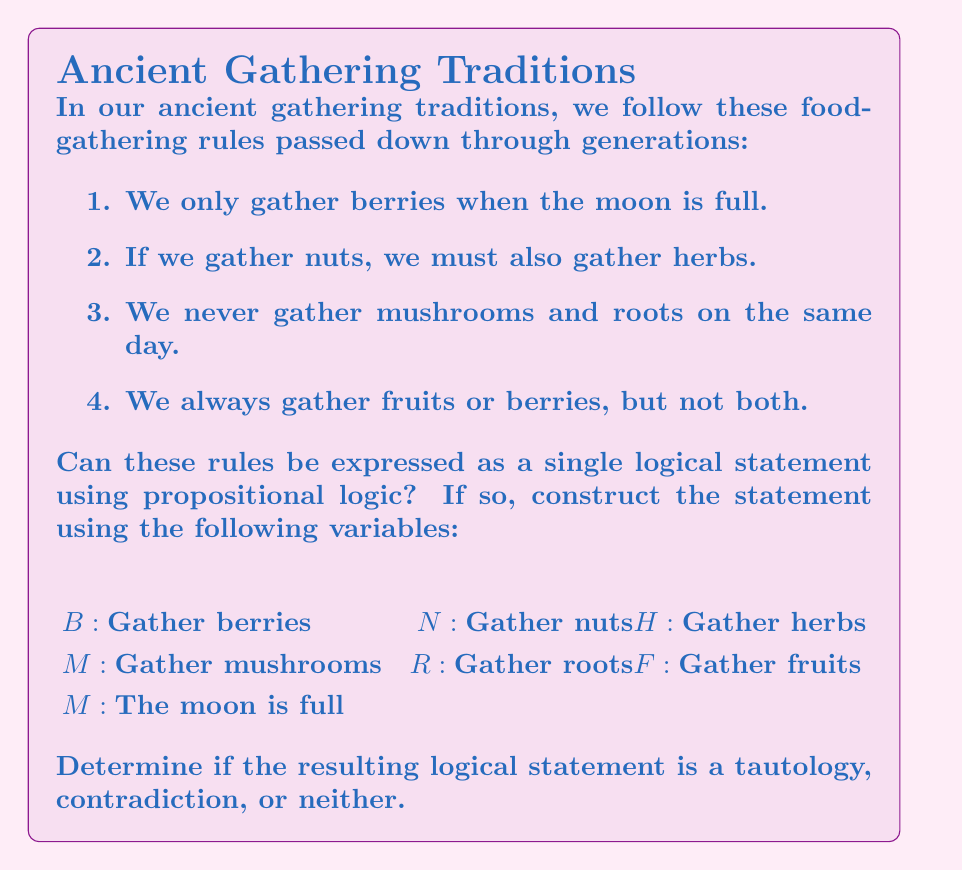Can you answer this question? Let's approach this step-by-step:

1) First, we need to translate each rule into a logical statement:

   Rule 1: $B \rightarrow M$
   Rule 2: $N \rightarrow H$
   Rule 3: $\neg(M \wedge R)$
   Rule 4: $(F \oplus B)$ (exclusive or)

2) Now, we combine these statements using conjunction ($\wedge$):

   $$(B \rightarrow M) \wedge (N \rightarrow H) \wedge \neg(M \wedge R) \wedge (F \oplus B)$$

3) This is our single logical statement representing all the rules.

4) To determine if this is a tautology, contradiction, or neither, we need to evaluate it for all possible combinations of truth values for the variables.

5) With 7 variables, we have $2^7 = 128$ possible combinations. This is too many to check manually, so we would typically use a truth table or a computer program.

6) Without exhaustive checking, we can reason about it:
   - The statement is not a tautology because we can find at least one false case. For example, if all variables are false, $(F \oplus B)$ would be false.
   - The statement is not a contradiction because we can find at least one true case. For example, if M is true, B is false, N is false, H is false, R is false, and F is true, the entire statement would be true.

7) Therefore, the statement is neither a tautology nor a contradiction. It's a contingency, which means its truth value depends on the specific values of the variables.
Answer: The rules can be expressed as: $$(B \rightarrow M) \wedge (N \rightarrow H) \wedge \neg(M \wedge R) \wedge (F \oplus B)$$
This statement is neither a tautology nor a contradiction. 